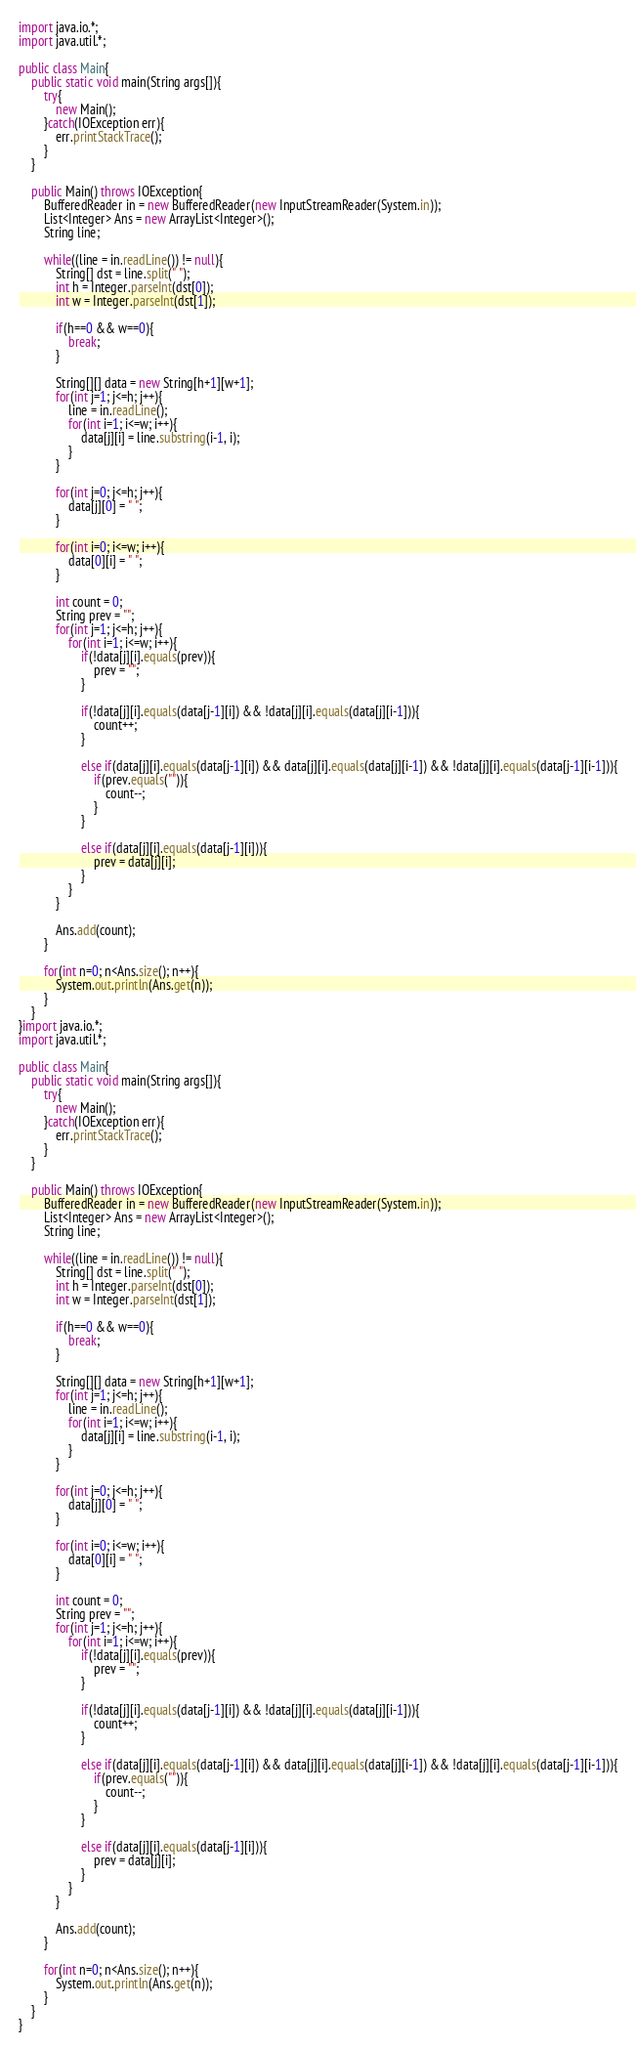Convert code to text. <code><loc_0><loc_0><loc_500><loc_500><_Java_>import java.io.*;
import java.util.*;

public class Main{
	public static void main(String args[]){
		try{
			new Main();
		}catch(IOException err){
			err.printStackTrace();
		}
	}

	public Main() throws IOException{
		BufferedReader in = new BufferedReader(new InputStreamReader(System.in));
		List<Integer> Ans = new ArrayList<Integer>();
		String line;

		while((line = in.readLine()) != null){
			String[] dst = line.split(" ");
			int h = Integer.parseInt(dst[0]);
			int w = Integer.parseInt(dst[1]);

			if(h==0 && w==0){
				break;
			}

			String[][] data = new String[h+1][w+1];
			for(int j=1; j<=h; j++){
				line = in.readLine();
				for(int i=1; i<=w; i++){
					data[j][i] = line.substring(i-1, i);
				}
			}

			for(int j=0; j<=h; j++){
				data[j][0] = " ";
			}

			for(int i=0; i<=w; i++){
				data[0][i] = " ";
			}

			int count = 0;
			String prev = "";
			for(int j=1; j<=h; j++){
				for(int i=1; i<=w; i++){
					if(!data[j][i].equals(prev)){
						prev = "";
					}

					if(!data[j][i].equals(data[j-1][i]) && !data[j][i].equals(data[j][i-1])){
						count++;
					}

					else if(data[j][i].equals(data[j-1][i]) && data[j][i].equals(data[j][i-1]) && !data[j][i].equals(data[j-1][i-1])){
						if(prev.equals("")){
							count--;
						}
					}

					else if(data[j][i].equals(data[j-1][i])){
						prev = data[j][i];
					}
				}
			}

			Ans.add(count);
		}

		for(int n=0; n<Ans.size(); n++){
			System.out.println(Ans.get(n));
		}
	}
}import java.io.*;
import java.util.*;

public class Main{
	public static void main(String args[]){
		try{
			new Main();
		}catch(IOException err){
			err.printStackTrace();
		}
	}

	public Main() throws IOException{
		BufferedReader in = new BufferedReader(new InputStreamReader(System.in));
		List<Integer> Ans = new ArrayList<Integer>();
		String line;

		while((line = in.readLine()) != null){
			String[] dst = line.split(" ");
			int h = Integer.parseInt(dst[0]);
			int w = Integer.parseInt(dst[1]);

			if(h==0 && w==0){
				break;
			}

			String[][] data = new String[h+1][w+1];
			for(int j=1; j<=h; j++){
				line = in.readLine();
				for(int i=1; i<=w; i++){
					data[j][i] = line.substring(i-1, i);
				}
			}

			for(int j=0; j<=h; j++){
				data[j][0] = " ";
			}

			for(int i=0; i<=w; i++){
				data[0][i] = " ";
			}

			int count = 0;
			String prev = "";
			for(int j=1; j<=h; j++){
				for(int i=1; i<=w; i++){
					if(!data[j][i].equals(prev)){
						prev = "";
					}

					if(!data[j][i].equals(data[j-1][i]) && !data[j][i].equals(data[j][i-1])){
						count++;
					}

					else if(data[j][i].equals(data[j-1][i]) && data[j][i].equals(data[j][i-1]) && !data[j][i].equals(data[j-1][i-1])){
						if(prev.equals("")){
							count--;
						}
					}

					else if(data[j][i].equals(data[j-1][i])){
						prev = data[j][i];
					}
				}
			}

			Ans.add(count);
		}

		for(int n=0; n<Ans.size(); n++){
			System.out.println(Ans.get(n));
		}
	}
}</code> 